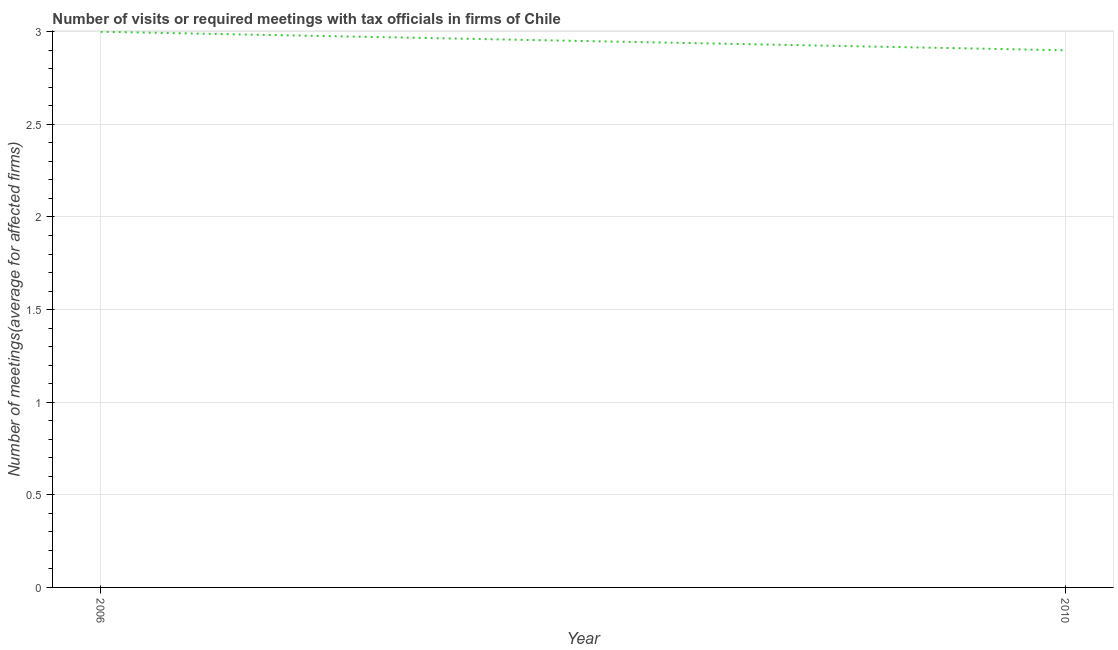What is the number of required meetings with tax officials in 2006?
Keep it short and to the point. 3. Across all years, what is the maximum number of required meetings with tax officials?
Keep it short and to the point. 3. In which year was the number of required meetings with tax officials minimum?
Make the answer very short. 2010. What is the difference between the number of required meetings with tax officials in 2006 and 2010?
Offer a very short reply. 0.1. What is the average number of required meetings with tax officials per year?
Offer a very short reply. 2.95. What is the median number of required meetings with tax officials?
Offer a very short reply. 2.95. Do a majority of the years between 2010 and 2006 (inclusive) have number of required meetings with tax officials greater than 1.7 ?
Your response must be concise. No. What is the ratio of the number of required meetings with tax officials in 2006 to that in 2010?
Your answer should be very brief. 1.03. Is the number of required meetings with tax officials in 2006 less than that in 2010?
Provide a short and direct response. No. How many lines are there?
Offer a very short reply. 1. How many years are there in the graph?
Keep it short and to the point. 2. What is the difference between two consecutive major ticks on the Y-axis?
Provide a short and direct response. 0.5. What is the title of the graph?
Your answer should be very brief. Number of visits or required meetings with tax officials in firms of Chile. What is the label or title of the Y-axis?
Offer a terse response. Number of meetings(average for affected firms). What is the Number of meetings(average for affected firms) in 2006?
Your answer should be compact. 3. What is the difference between the Number of meetings(average for affected firms) in 2006 and 2010?
Keep it short and to the point. 0.1. What is the ratio of the Number of meetings(average for affected firms) in 2006 to that in 2010?
Keep it short and to the point. 1.03. 